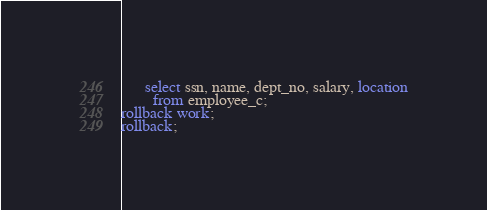Convert code to text. <code><loc_0><loc_0><loc_500><loc_500><_SQL_>      select ssn, name, dept_no, salary, location
        from employee_c;
rollback work;
rollback;
</code> 